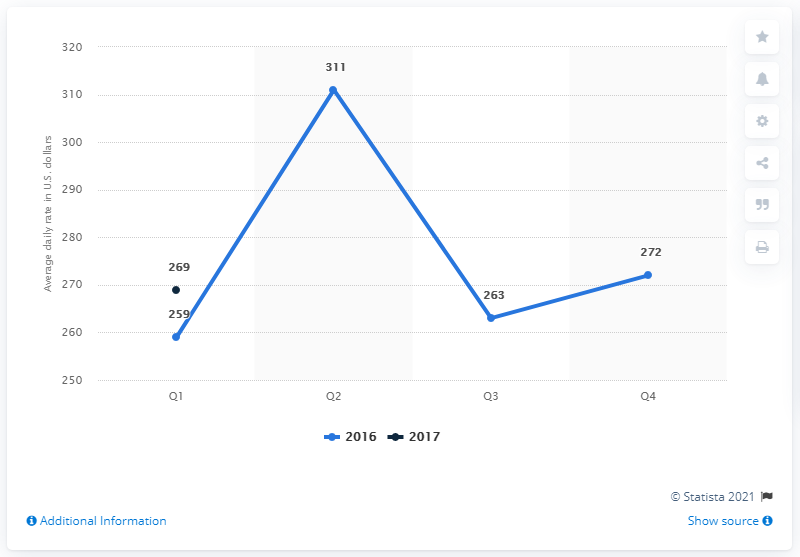List a handful of essential elements in this visual. In the first quarter of 2017, the average daily rate of hotels in Washington D.C. was $269. 